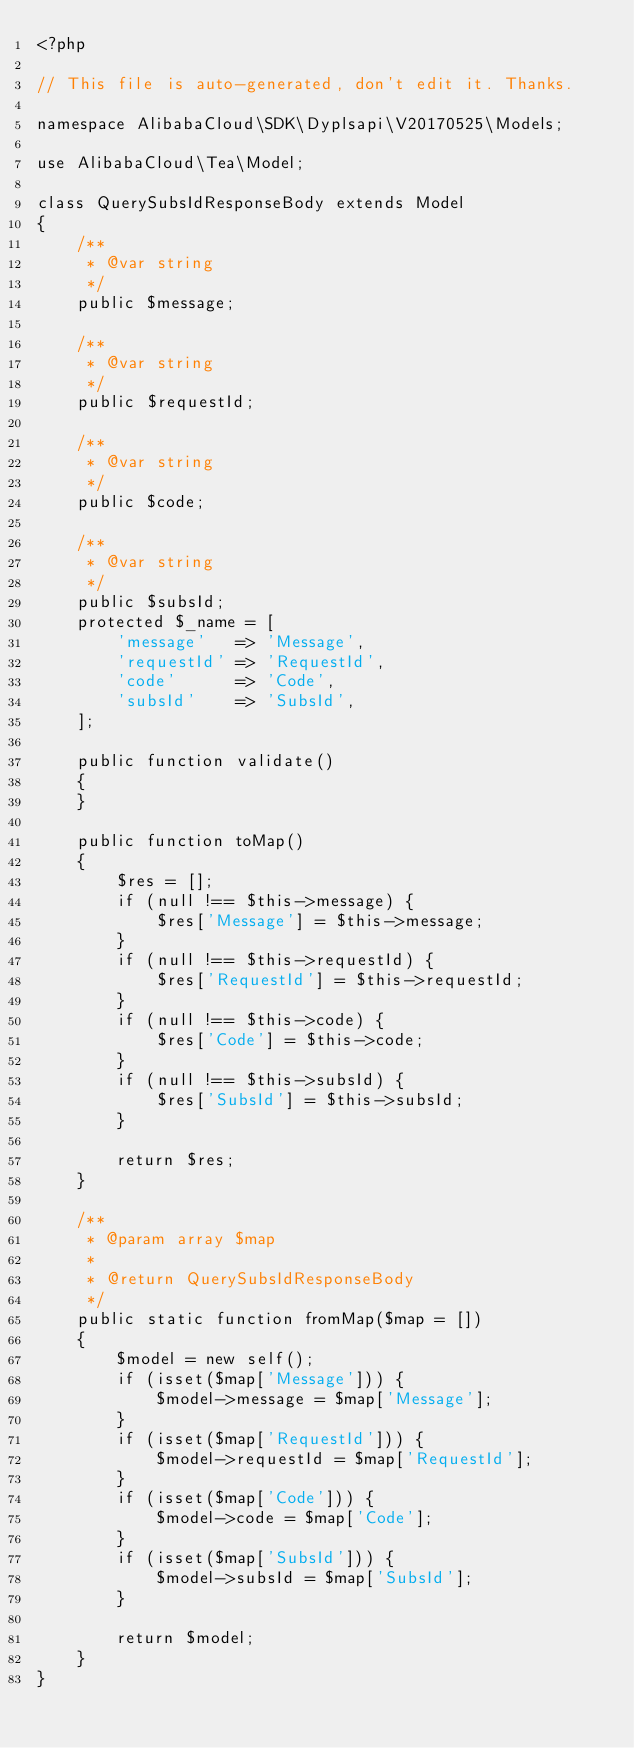<code> <loc_0><loc_0><loc_500><loc_500><_PHP_><?php

// This file is auto-generated, don't edit it. Thanks.

namespace AlibabaCloud\SDK\Dyplsapi\V20170525\Models;

use AlibabaCloud\Tea\Model;

class QuerySubsIdResponseBody extends Model
{
    /**
     * @var string
     */
    public $message;

    /**
     * @var string
     */
    public $requestId;

    /**
     * @var string
     */
    public $code;

    /**
     * @var string
     */
    public $subsId;
    protected $_name = [
        'message'   => 'Message',
        'requestId' => 'RequestId',
        'code'      => 'Code',
        'subsId'    => 'SubsId',
    ];

    public function validate()
    {
    }

    public function toMap()
    {
        $res = [];
        if (null !== $this->message) {
            $res['Message'] = $this->message;
        }
        if (null !== $this->requestId) {
            $res['RequestId'] = $this->requestId;
        }
        if (null !== $this->code) {
            $res['Code'] = $this->code;
        }
        if (null !== $this->subsId) {
            $res['SubsId'] = $this->subsId;
        }

        return $res;
    }

    /**
     * @param array $map
     *
     * @return QuerySubsIdResponseBody
     */
    public static function fromMap($map = [])
    {
        $model = new self();
        if (isset($map['Message'])) {
            $model->message = $map['Message'];
        }
        if (isset($map['RequestId'])) {
            $model->requestId = $map['RequestId'];
        }
        if (isset($map['Code'])) {
            $model->code = $map['Code'];
        }
        if (isset($map['SubsId'])) {
            $model->subsId = $map['SubsId'];
        }

        return $model;
    }
}
</code> 